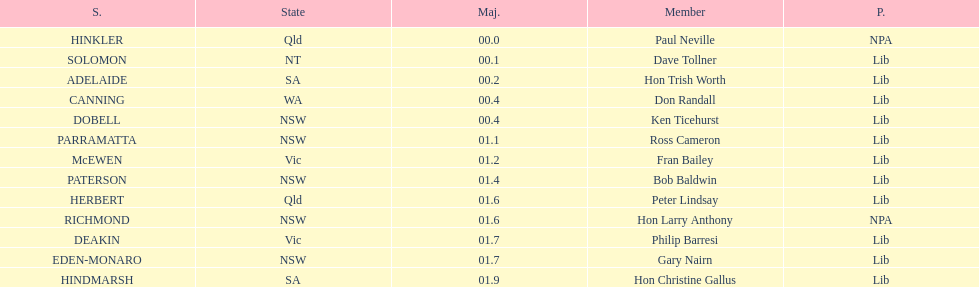What was the total majority that the dobell seat had? 00.4. 